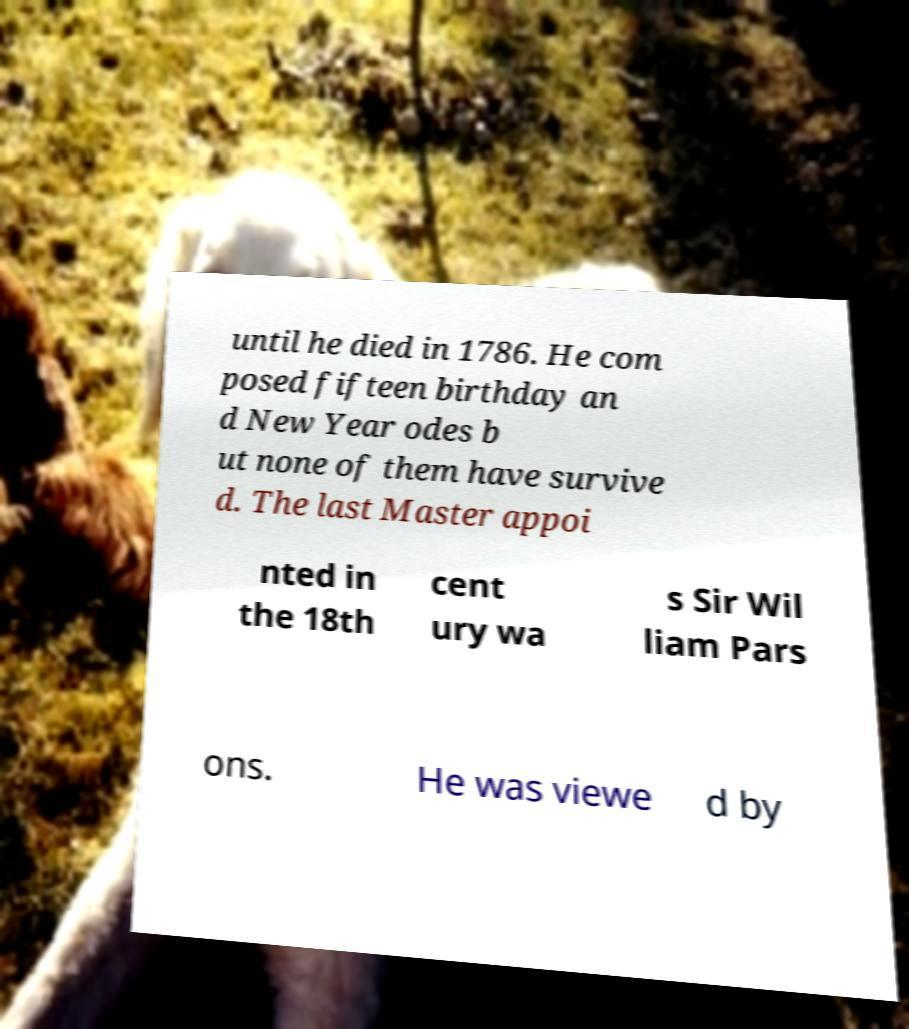Could you assist in decoding the text presented in this image and type it out clearly? until he died in 1786. He com posed fifteen birthday an d New Year odes b ut none of them have survive d. The last Master appoi nted in the 18th cent ury wa s Sir Wil liam Pars ons. He was viewe d by 